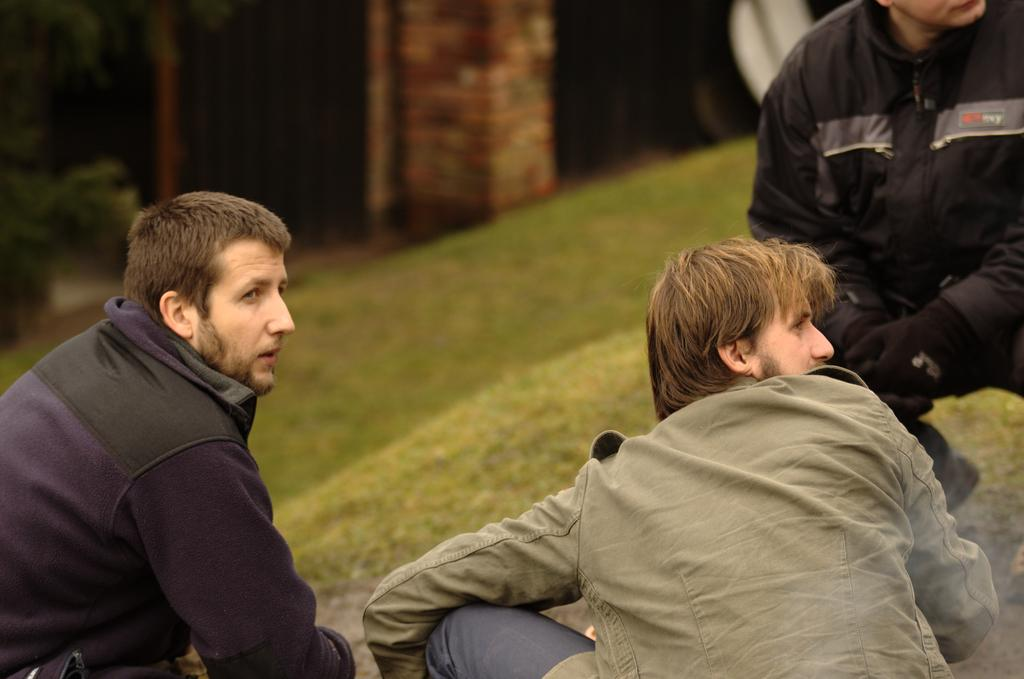What are the people in the image doing? The people in the image are bending. What can be seen in the background of the image? There are trees and a pillar in the background of the image. What is visible at the bottom of the image? The ground is visible at the bottom of the image. What type of cookbook is lying on the ground in the image? There is no cookbook or any book present in the image. How many birds are in the flock that is visible in the image? There is no flock or birds present in the image. 